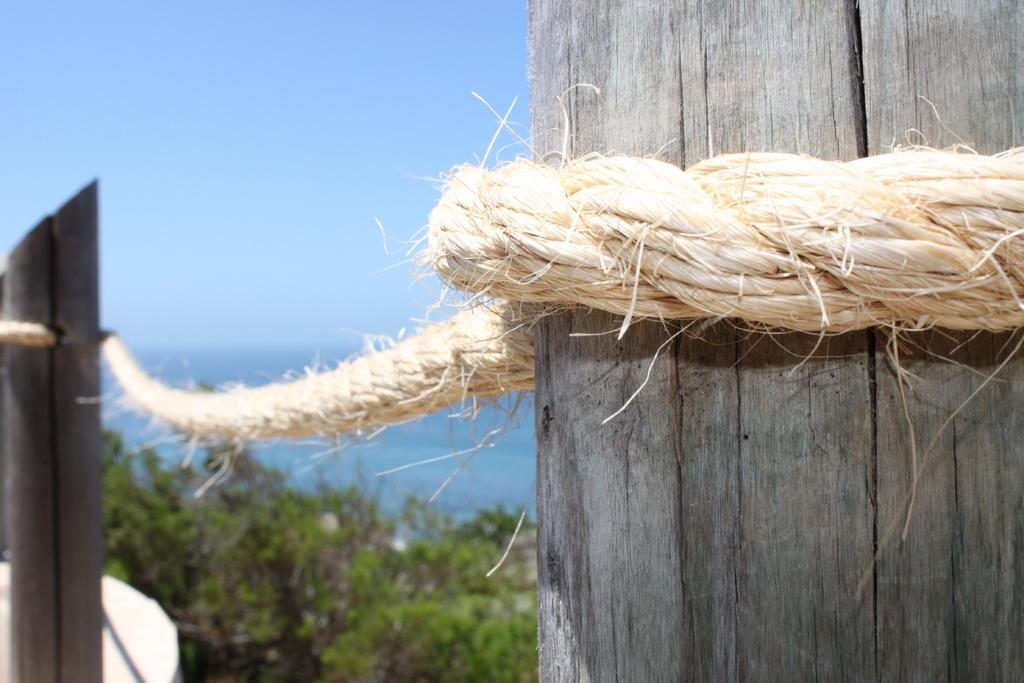Can you describe this image briefly? In this image we can see wooden poles tied with a rope like a barrier. In the background we can see trees and sky. 